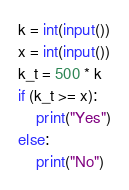Convert code to text. <code><loc_0><loc_0><loc_500><loc_500><_Python_>k = int(input())
x = int(input())
k_t = 500 * k
if (k_t >= x):
    print("Yes")
else:
    print("No")</code> 